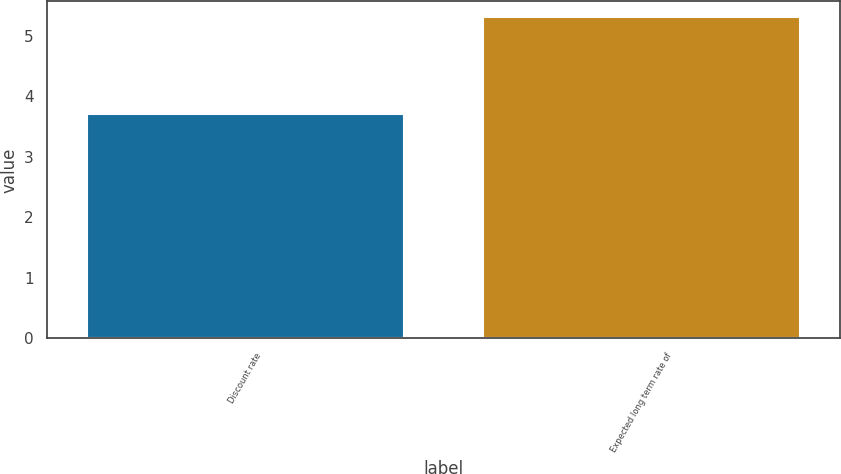Convert chart. <chart><loc_0><loc_0><loc_500><loc_500><bar_chart><fcel>Discount rate<fcel>Expected long term rate of<nl><fcel>3.7<fcel>5.3<nl></chart> 